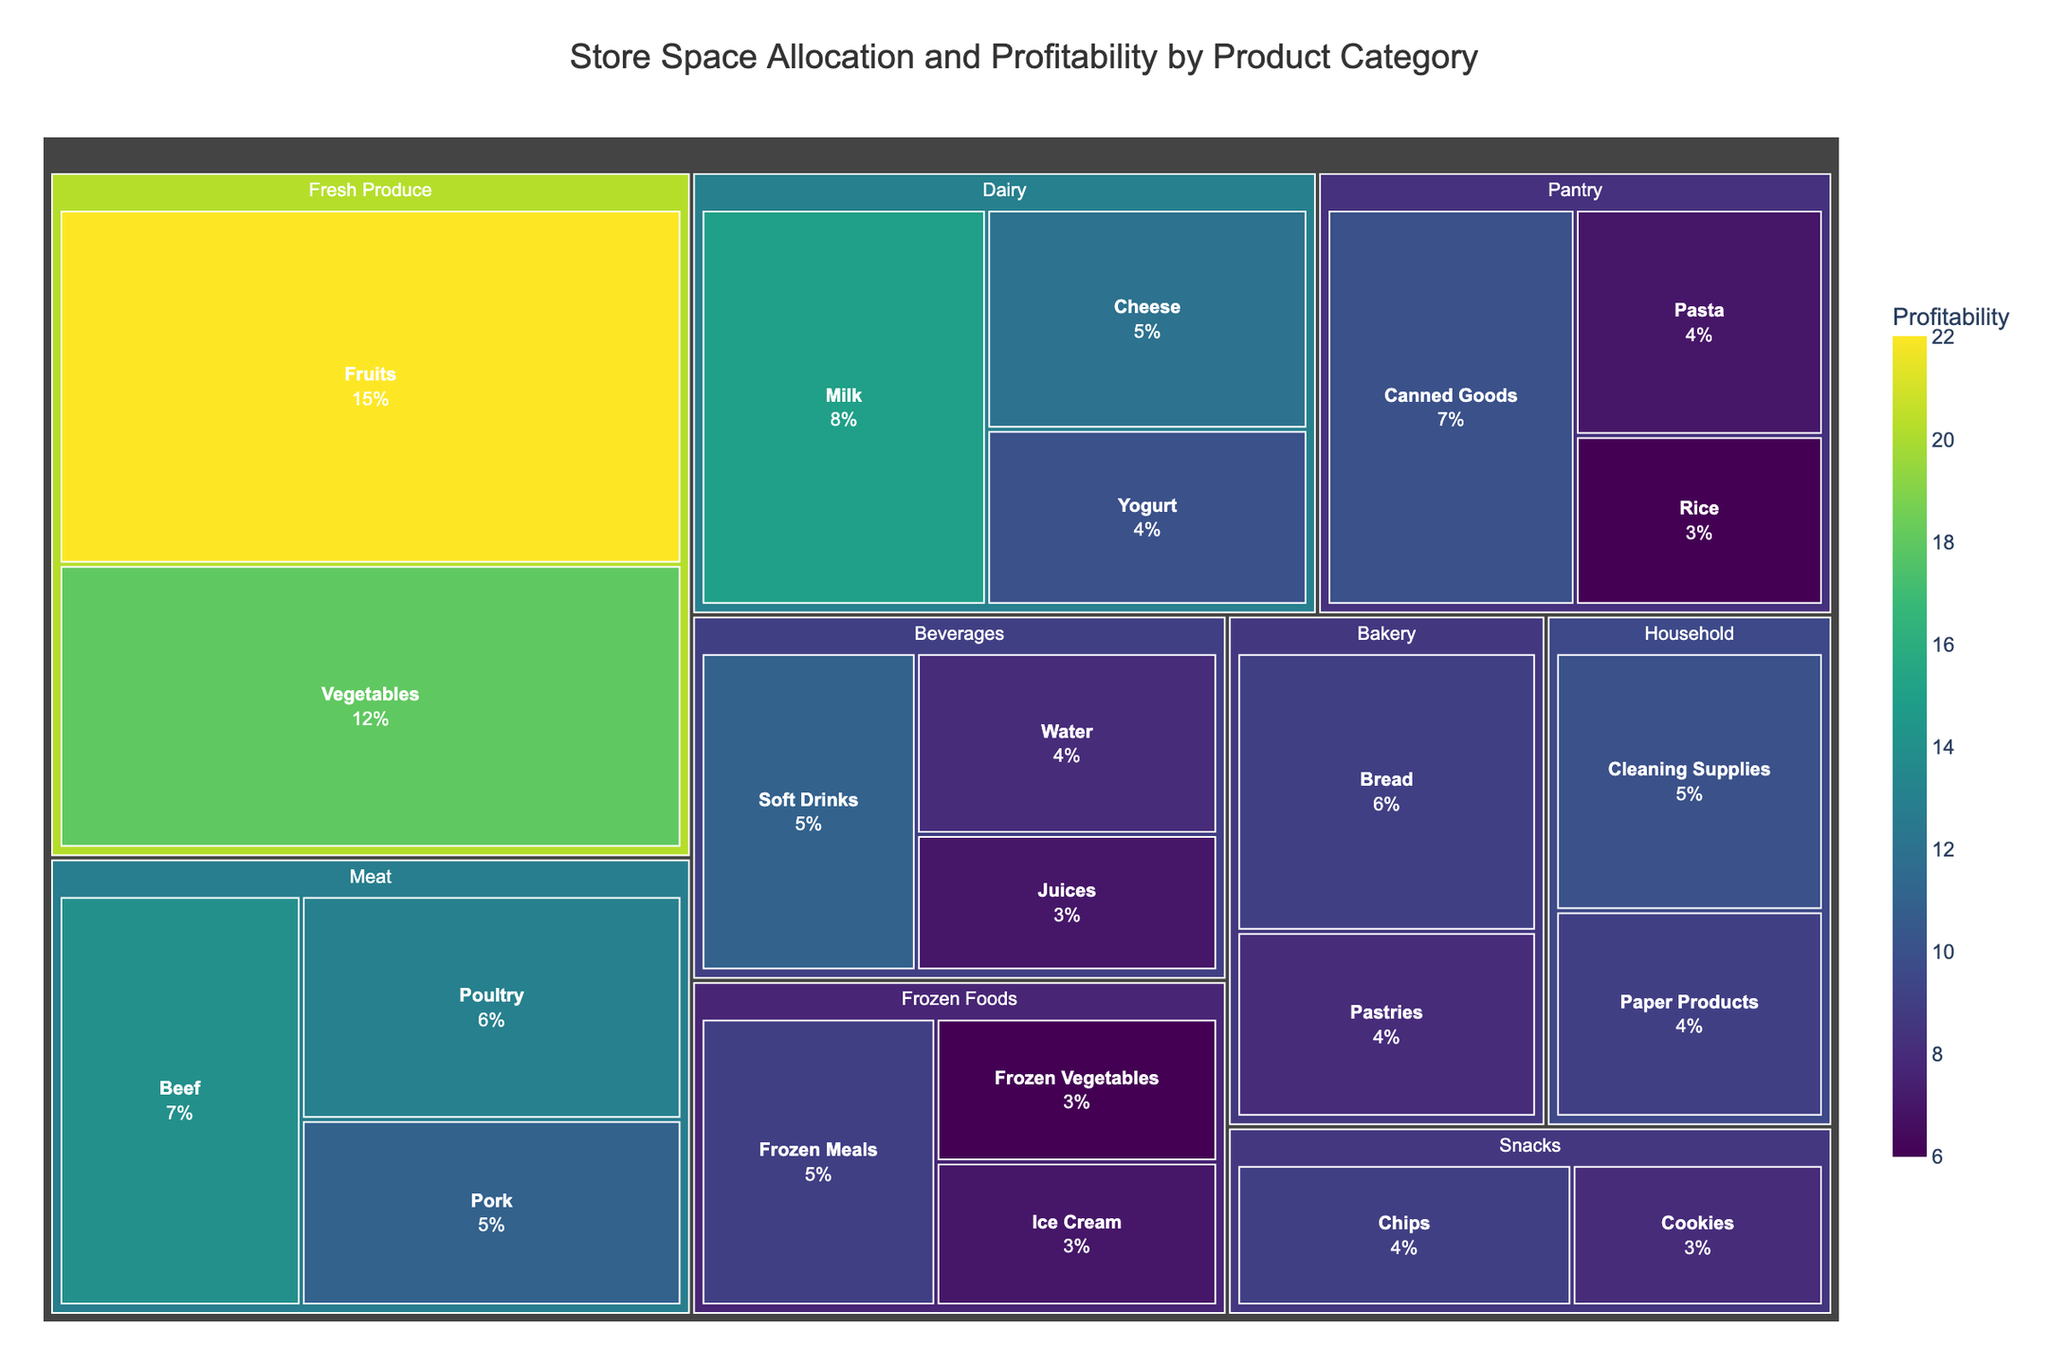Which category has the largest space allocation? By looking at the treemap, the area of each rectangle represents the space allocation. The largest area corresponds to the "Fresh Produce" category.
Answer: Fresh Produce Which subcategory under Meat has the highest profitability? Within the Meat category, comparing the profitability values of Beef (14), Poultry (13), and Pork (11), Beef has the highest profitability.
Answer: Beef What is the average profitability of the Dairy subcategories? Adding the profitability of Milk (15), Cheese (12), and Yogurt (10) gives 37. Dividing this by the number of subcategories (3) results in 37/3 = 12.33.
Answer: 12.33 How does the space allocation of Frozen Foods compare to Beverages? Summing the space allocations of subcategories under Frozen Foods (Ice Cream 3 + Frozen Meals 5 + Frozen Vegetables 3) and under Beverages (Soft Drinks 5 + Water 4 + Juices 3) results in Frozen Foods having 11% and Beverages having 12%. Therefore, Beverages has a slightly larger space allocation than Frozen Foods.
Answer: Beverages has slightly more What is the subcategory with the lowest profitability in the Fresh Produce category? Comparing the profitability of Fruits (22) and Vegetables (18), Vegetables has the lower profitability.
Answer: Vegetables Compare the space allocation between Snacks and Bakery categories. Which has more? Adding the space allocations for Snacks (Chips 4 + Cookies 3) and Bakery (Bread 6 + Pastries 4) results in Snacks having 7% and Bakery having 10%. Thus, Bakery has more space allocation.
Answer: Bakery Which category has the lowest overall space allocation? Looking at all categories, Frozen Foods has space allocations of Ice Cream (3), Frozen Meals (5), and Frozen Vegetables (3), making it 11%. This is the lowest overall compared to other categories.
Answer: Frozen Foods What is the total space allocated to the Pantry category? Summing the space allocated to Canned Goods (7), Pasta (4), and Rice (3) results in a total of 14%.
Answer: 14% Which subcategory under Beverages has higher profitability, Soft Drinks or Juices? By comparing the profitability values, Soft Drinks have profitability of 11 and Juices have 7. Soft Drinks have higher profitability.
Answer: Soft Drinks What is the range of profitability values across all categories? The highest profitability value is for Fruits (22) and the lowest is for Frozen Vegetables (6). The range is 22 - 6 = 16.
Answer: 16 